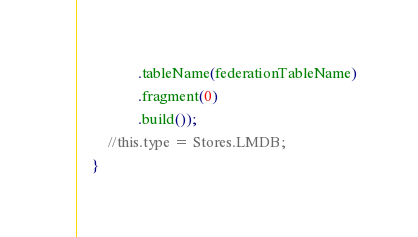Convert code to text. <code><loc_0><loc_0><loc_500><loc_500><_Java_>                .tableName(federationTableName)
                .fragment(0)
                .build());
        //this.type = Stores.LMDB;
    }
</code> 